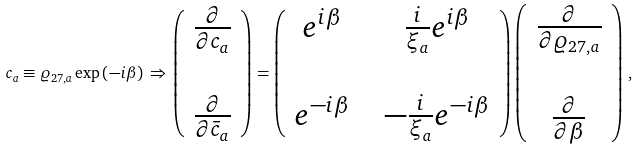<formula> <loc_0><loc_0><loc_500><loc_500>c _ { a } \equiv \varrho _ { 2 7 , a } \exp \left ( - i \beta \right ) \, \Rightarrow \, \left ( \begin{array} { c } \frac { \partial } { \partial c _ { a } } \\ \\ \frac { \partial } { \partial \bar { c } _ { a } } \end{array} \right ) = \left ( \begin{array} { c c c } e ^ { i \beta } & & \frac { i } { \xi _ { a } } e ^ { i \beta } \\ & & \\ e ^ { - i \beta } & & - \frac { i } { \xi _ { a } } e ^ { - i \beta } \end{array} \right ) \left ( \begin{array} { c } \frac { \partial } { \partial \varrho _ { 2 7 , a } } \\ \\ \frac { \partial } { \partial \beta } \end{array} \right ) \, ,</formula> 